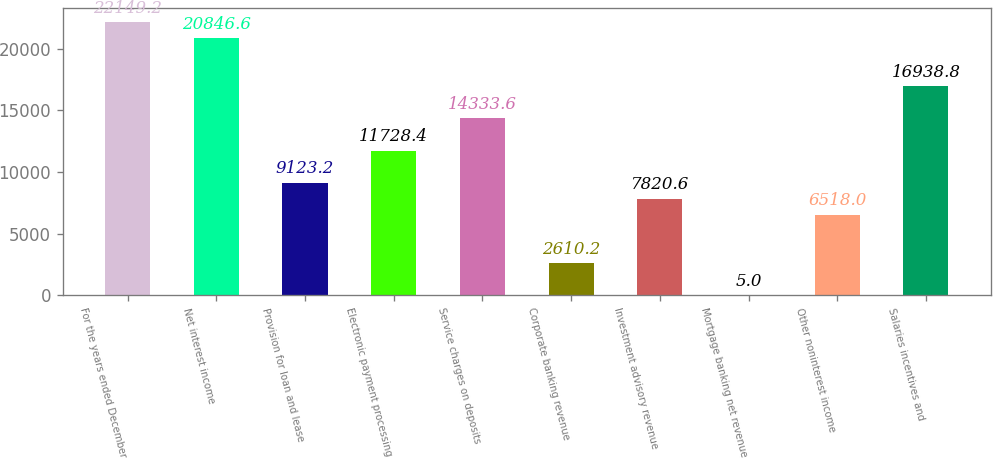Convert chart to OTSL. <chart><loc_0><loc_0><loc_500><loc_500><bar_chart><fcel>For the years ended December<fcel>Net interest income<fcel>Provision for loan and lease<fcel>Electronic payment processing<fcel>Service charges on deposits<fcel>Corporate banking revenue<fcel>Investment advisory revenue<fcel>Mortgage banking net revenue<fcel>Other noninterest income<fcel>Salaries incentives and<nl><fcel>22149.2<fcel>20846.6<fcel>9123.2<fcel>11728.4<fcel>14333.6<fcel>2610.2<fcel>7820.6<fcel>5<fcel>6518<fcel>16938.8<nl></chart> 